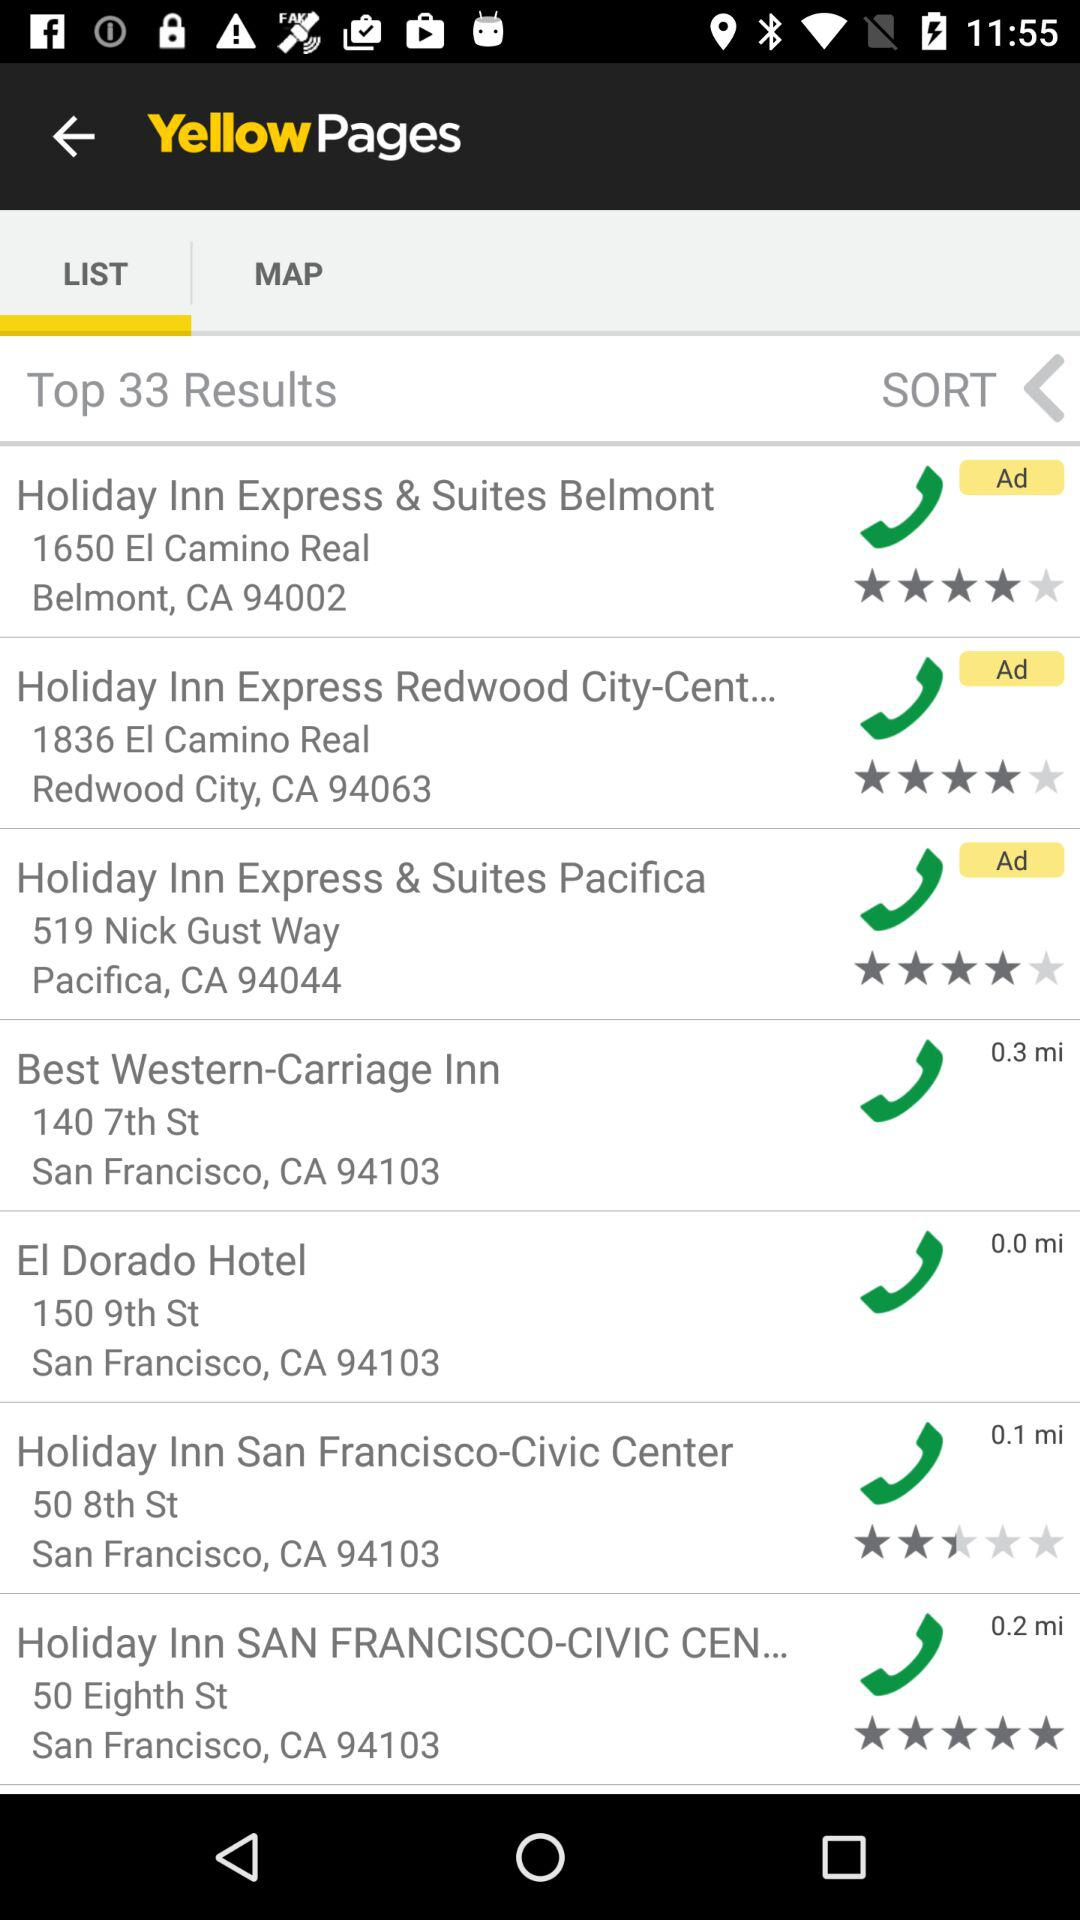How far is "El Dorado Hotel" from my location? "El Dorado Hotel" is 0 miles from your location. 